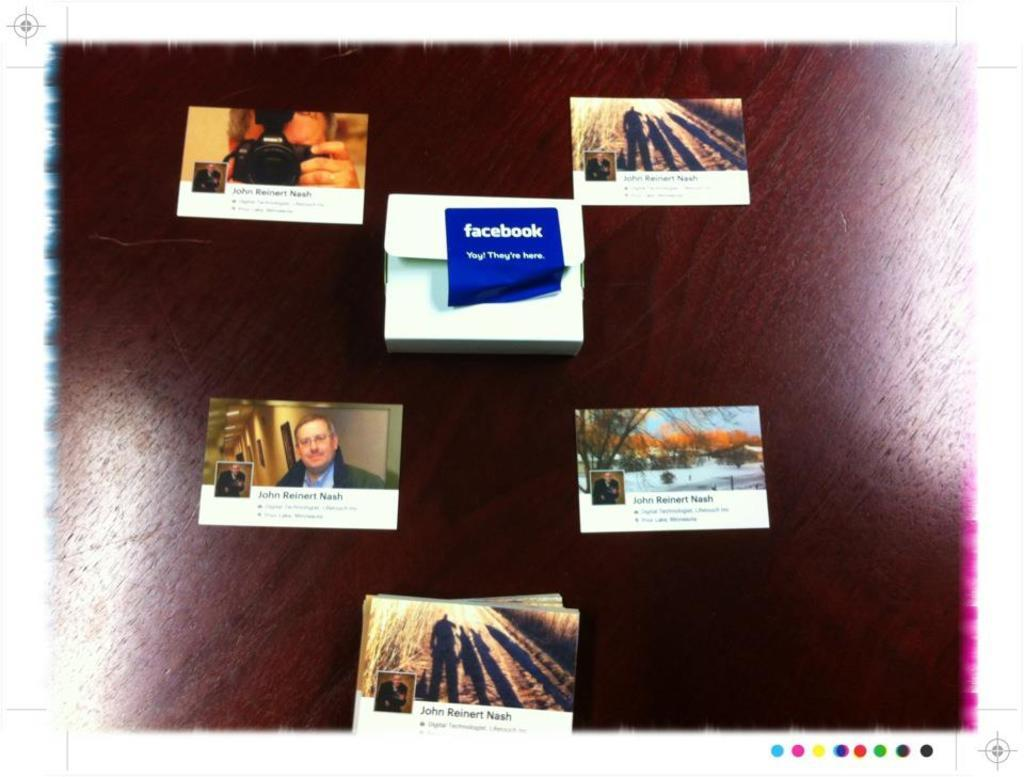Provide a one-sentence caption for the provided image. several pictures against a brown background, one showing a facebook logo. 